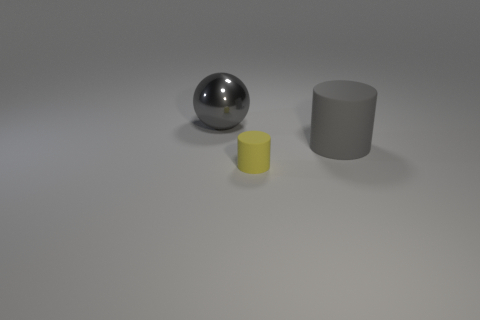Add 3 large blue metallic things. How many objects exist? 6 Add 3 small yellow cylinders. How many small yellow cylinders are left? 4 Add 2 gray metal balls. How many gray metal balls exist? 3 Subtract 0 purple cubes. How many objects are left? 3 Subtract all cylinders. How many objects are left? 1 Subtract all gray cylinders. Subtract all tiny yellow cylinders. How many objects are left? 1 